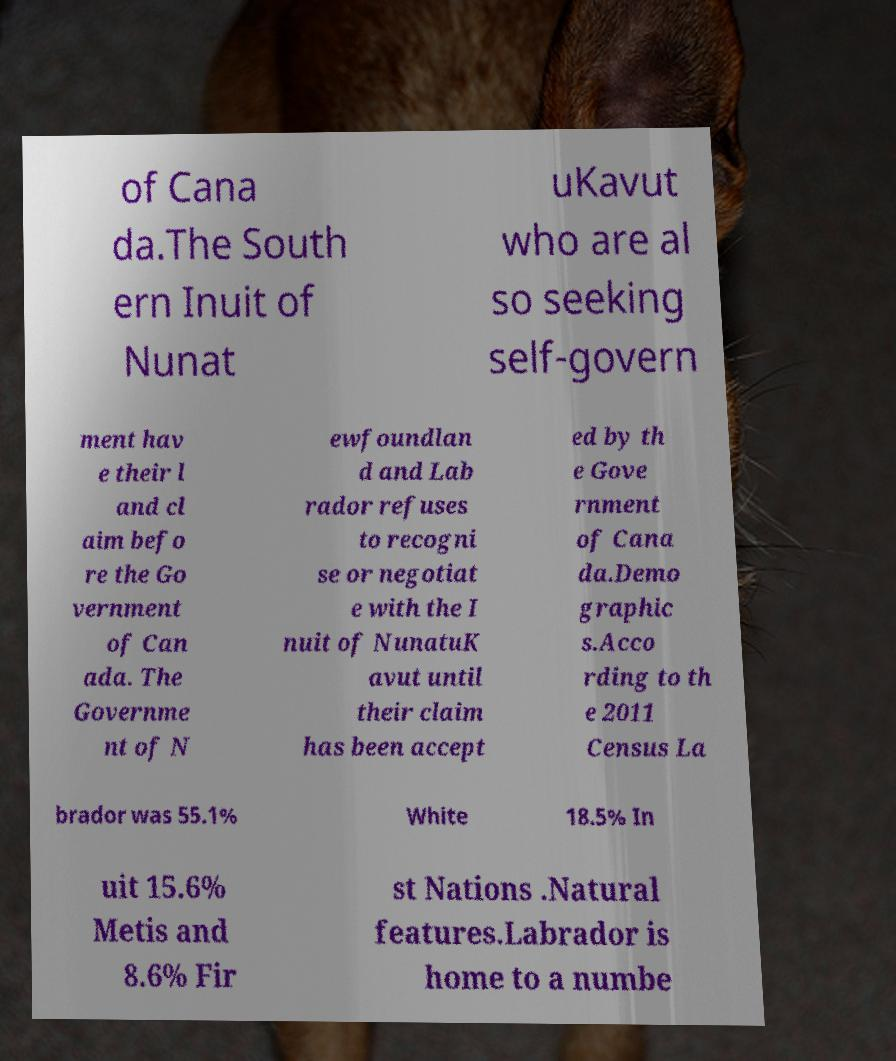Can you accurately transcribe the text from the provided image for me? of Cana da.The South ern Inuit of Nunat uKavut who are al so seeking self-govern ment hav e their l and cl aim befo re the Go vernment of Can ada. The Governme nt of N ewfoundlan d and Lab rador refuses to recogni se or negotiat e with the I nuit of NunatuK avut until their claim has been accept ed by th e Gove rnment of Cana da.Demo graphic s.Acco rding to th e 2011 Census La brador was 55.1% White 18.5% In uit 15.6% Metis and 8.6% Fir st Nations .Natural features.Labrador is home to a numbe 